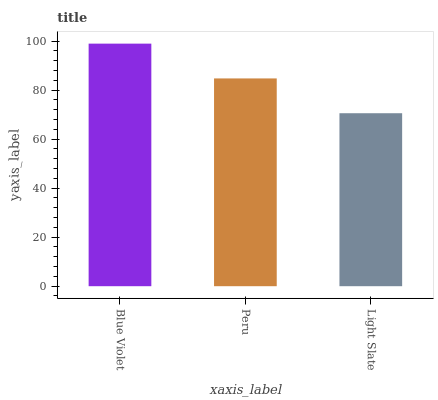Is Light Slate the minimum?
Answer yes or no. Yes. Is Blue Violet the maximum?
Answer yes or no. Yes. Is Peru the minimum?
Answer yes or no. No. Is Peru the maximum?
Answer yes or no. No. Is Blue Violet greater than Peru?
Answer yes or no. Yes. Is Peru less than Blue Violet?
Answer yes or no. Yes. Is Peru greater than Blue Violet?
Answer yes or no. No. Is Blue Violet less than Peru?
Answer yes or no. No. Is Peru the high median?
Answer yes or no. Yes. Is Peru the low median?
Answer yes or no. Yes. Is Blue Violet the high median?
Answer yes or no. No. Is Blue Violet the low median?
Answer yes or no. No. 